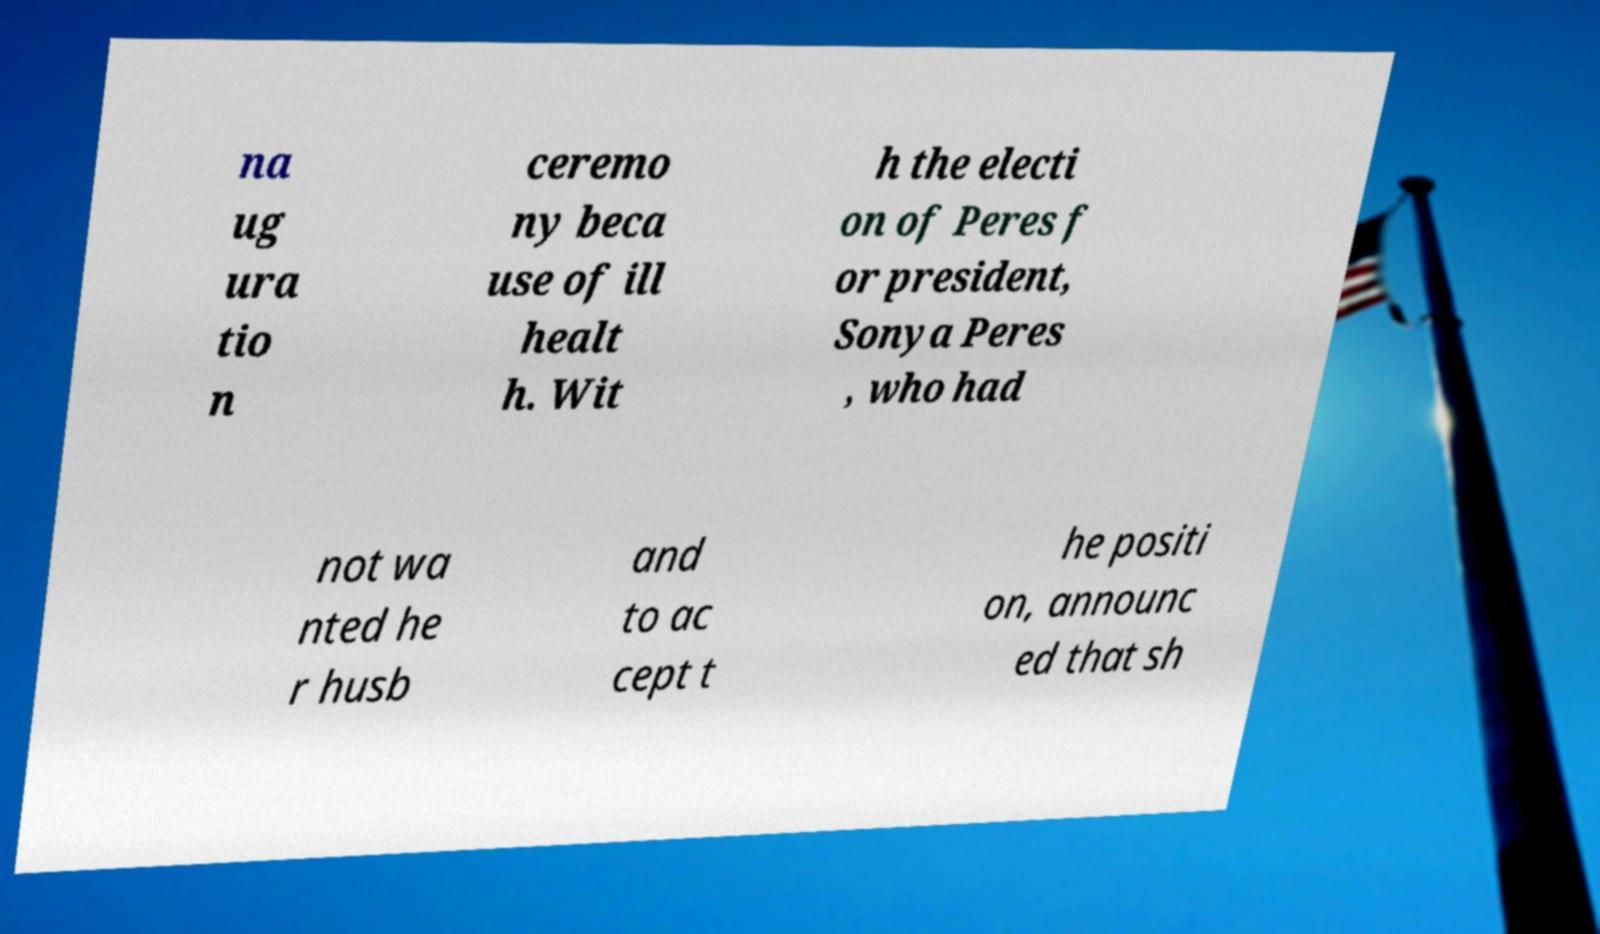Can you read and provide the text displayed in the image?This photo seems to have some interesting text. Can you extract and type it out for me? na ug ura tio n ceremo ny beca use of ill healt h. Wit h the electi on of Peres f or president, Sonya Peres , who had not wa nted he r husb and to ac cept t he positi on, announc ed that sh 